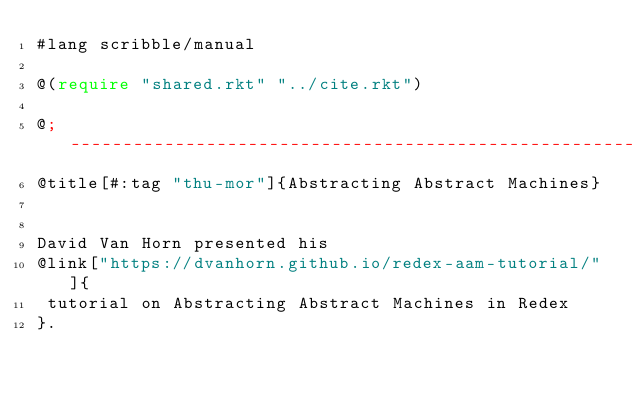Convert code to text. <code><loc_0><loc_0><loc_500><loc_500><_Racket_>#lang scribble/manual

@(require "shared.rkt" "../cite.rkt")

@; ---------------------------------------------------------------------------------------------------
@title[#:tag "thu-mor"]{Abstracting Abstract Machines} 


David Van Horn presented his
@link["https://dvanhorn.github.io/redex-aam-tutorial/"]{
 tutorial on Abstracting Abstract Machines in Redex
}.
</code> 